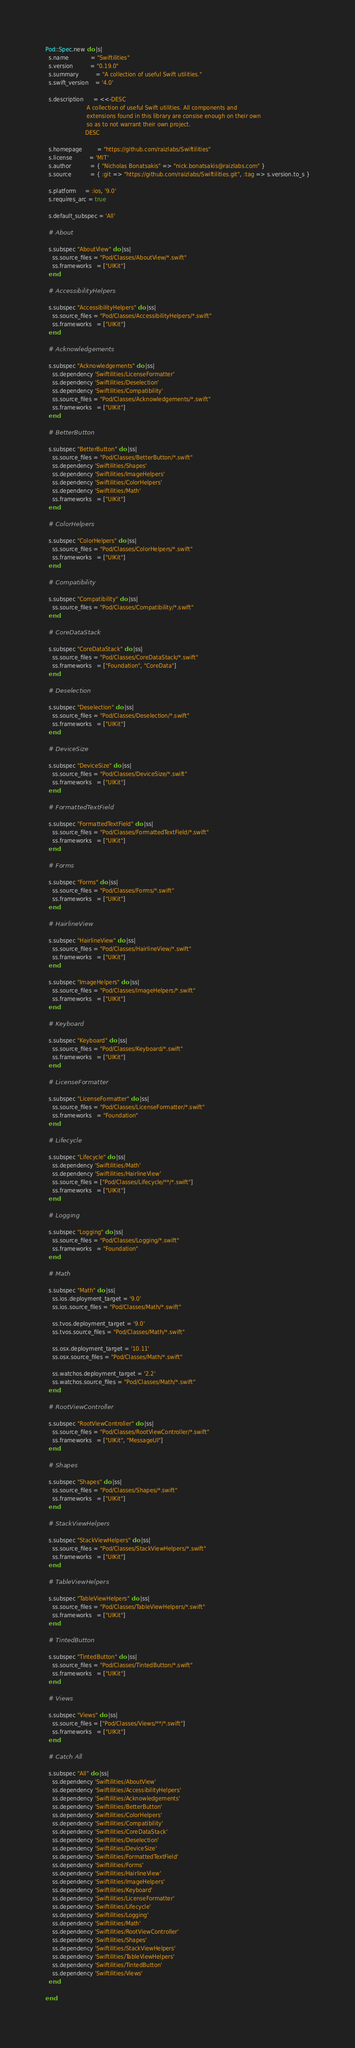<code> <loc_0><loc_0><loc_500><loc_500><_Ruby_>Pod::Spec.new do |s|
  s.name             = "Swiftilities"
  s.version          = "0.19.0"
  s.summary          = "A collection of useful Swift utilities."
  s.swift_version    = '4.0'

  s.description      = <<-DESC
                        A collection of useful Swift utilities. All components and
                        extensions found in this library are consise enough on their own
                        so as to not warrant their own project.
                       DESC

  s.homepage         = "https://github.com/raizlabs/Swiftilities"
  s.license          = 'MIT'
  s.author           = { "Nicholas Bonatsakis" => "nick.bonatsakis@raizlabs.com" }
  s.source           = { :git => "https://github.com/raizlabs/Swiftilities.git", :tag => s.version.to_s }

  s.platform     = :ios, '9.0'
  s.requires_arc = true

  s.default_subspec = 'All'

  # About

  s.subspec "AboutView" do |ss|
    ss.source_files = "Pod/Classes/AboutView/*.swift"
    ss.frameworks   = ["UIKit"]
  end

  # AccessibilityHelpers

  s.subspec "AccessibilityHelpers" do |ss|
    ss.source_files = "Pod/Classes/AccessibilityHelpers/*.swift"
    ss.frameworks   = ["UIKit"]
  end

  # Acknowledgements

  s.subspec "Acknowledgements" do |ss|
    ss.dependency 'Swiftilities/LicenseFormatter'
    ss.dependency 'Swiftilities/Deselection'
    ss.dependency 'Swiftilities/Compatibility'
    ss.source_files = "Pod/Classes/Acknowledgements/*.swift"
    ss.frameworks   = ["UIKit"]
  end

  # BetterButton
  
  s.subspec "BetterButton" do |ss|
    ss.source_files = "Pod/Classes/BetterButton/*.swift"
    ss.dependency 'Swiftilities/Shapes'
    ss.dependency 'Swiftilities/ImageHelpers'
    ss.dependency 'Swiftilities/ColorHelpers'
    ss.dependency 'Swiftilities/Math'
    ss.frameworks   = ["UIKit"]
  end

  # ColorHelpers

  s.subspec "ColorHelpers" do |ss|
    ss.source_files = "Pod/Classes/ColorHelpers/*.swift"
    ss.frameworks   = ["UIKit"]
  end

  # Compatibility

  s.subspec "Compatibility" do |ss|
    ss.source_files = "Pod/Classes/Compatibility/*.swift"
  end

  # CoreDataStack

  s.subspec "CoreDataStack" do |ss|
    ss.source_files = "Pod/Classes/CoreDataStack/*.swift"
    ss.frameworks   = ["Foundation", "CoreData"]
  end

  # Deselection

  s.subspec "Deselection" do |ss|
    ss.source_files = "Pod/Classes/Deselection/*.swift"
    ss.frameworks   = ["UIKit"]
  end

  # DeviceSize

  s.subspec "DeviceSize" do |ss|
    ss.source_files = "Pod/Classes/DeviceSize/*.swift"
    ss.frameworks   = ["UIKit"]
  end

  # FormattedTextField

  s.subspec "FormattedTextField" do |ss|
    ss.source_files = "Pod/Classes/FormattedTextField/*.swift"
    ss.frameworks   = ["UIKit"]
  end

  # Forms

  s.subspec "Forms" do |ss|
    ss.source_files = "Pod/Classes/Forms/*.swift"
    ss.frameworks   = ["UIKit"]
  end

  # HairlineView

  s.subspec "HairlineView" do |ss|
    ss.source_files = "Pod/Classes/HairlineView/*.swift"
    ss.frameworks   = ["UIKit"]
  end
  
  s.subspec "ImageHelpers" do |ss|
    ss.source_files = "Pod/Classes/ImageHelpers/*.swift"
    ss.frameworks   = ["UIKit"]
  end

  # Keyboard

  s.subspec "Keyboard" do |ss|
    ss.source_files = "Pod/Classes/Keyboard/*.swift"
    ss.frameworks   = ["UIKit"]
  end

  # LicenseFormatter

  s.subspec "LicenseFormatter" do |ss|
    ss.source_files = "Pod/Classes/LicenseFormatter/*.swift"
    ss.frameworks   = "Foundation"
  end

  # Lifecycle

  s.subspec "Lifecycle" do |ss|
    ss.dependency 'Swiftilities/Math'
    ss.dependency 'Swiftilities/HairlineView'
    ss.source_files = ["Pod/Classes/Lifecycle/**/*.swift"]
    ss.frameworks   = ["UIKit"]
  end

  # Logging

  s.subspec "Logging" do |ss|
    ss.source_files = "Pod/Classes/Logging/*.swift"
    ss.frameworks   = "Foundation"
  end

  # Math

  s.subspec "Math" do |ss|
    ss.ios.deployment_target = '9.0'
    ss.ios.source_files = "Pod/Classes/Math/*.swift"

    ss.tvos.deployment_target = '9.0'
    ss.tvos.source_files = "Pod/Classes/Math/*.swift"

    ss.osx.deployment_target = '10.11'
    ss.osx.source_files = "Pod/Classes/Math/*.swift"

    ss.watchos.deployment_target = '2.2'
    ss.watchos.source_files = "Pod/Classes/Math/*.swift"
  end

  # RootViewController

  s.subspec "RootViewController" do |ss|
    ss.source_files = "Pod/Classes/RootViewController/*.swift"
    ss.frameworks   = ["UIKit", "MessageUI"]
  end

  # Shapes

  s.subspec "Shapes" do |ss|
    ss.source_files = "Pod/Classes/Shapes/*.swift"
    ss.frameworks   = ["UIKit"]
  end

  # StackViewHelpers

  s.subspec "StackViewHelpers" do |ss|
    ss.source_files = "Pod/Classes/StackViewHelpers/*.swift"
    ss.frameworks   = ["UIKit"]
  end
  
  # TableViewHelpers

  s.subspec "TableViewHelpers" do |ss|
    ss.source_files = "Pod/Classes/TableViewHelpers/*.swift"
    ss.frameworks   = ["UIKit"]
  end

  # TintedButton

  s.subspec "TintedButton" do |ss|
    ss.source_files = "Pod/Classes/TintedButton/*.swift"
    ss.frameworks   = ["UIKit"]
  end

  # Views

  s.subspec "Views" do |ss|
    ss.source_files = ["Pod/Classes/Views/**/*.swift"]
    ss.frameworks   = ["UIKit"]
  end

  # Catch All

  s.subspec "All" do |ss|
    ss.dependency 'Swiftilities/AboutView'
    ss.dependency 'Swiftilities/AccessibilityHelpers'
    ss.dependency 'Swiftilities/Acknowledgements'
    ss.dependency 'Swiftilities/BetterButton'
    ss.dependency 'Swiftilities/ColorHelpers'
    ss.dependency 'Swiftilities/Compatibility'
    ss.dependency 'Swiftilities/CoreDataStack'
    ss.dependency 'Swiftilities/Deselection'
    ss.dependency 'Swiftilities/DeviceSize'
    ss.dependency 'Swiftilities/FormattedTextField'
    ss.dependency 'Swiftilities/Forms'
    ss.dependency 'Swiftilities/HairlineView'
    ss.dependency 'Swiftilities/ImageHelpers'
    ss.dependency 'Swiftilities/Keyboard'
    ss.dependency 'Swiftilities/LicenseFormatter'
    ss.dependency 'Swiftilities/Lifecycle'
    ss.dependency 'Swiftilities/Logging'
    ss.dependency 'Swiftilities/Math'
    ss.dependency 'Swiftilities/RootViewController'
    ss.dependency 'Swiftilities/Shapes'
    ss.dependency 'Swiftilities/StackViewHelpers'
    ss.dependency 'Swiftilities/TableViewHelpers'
    ss.dependency 'Swiftilities/TintedButton'
    ss.dependency 'Swiftilities/Views'
  end

end
</code> 